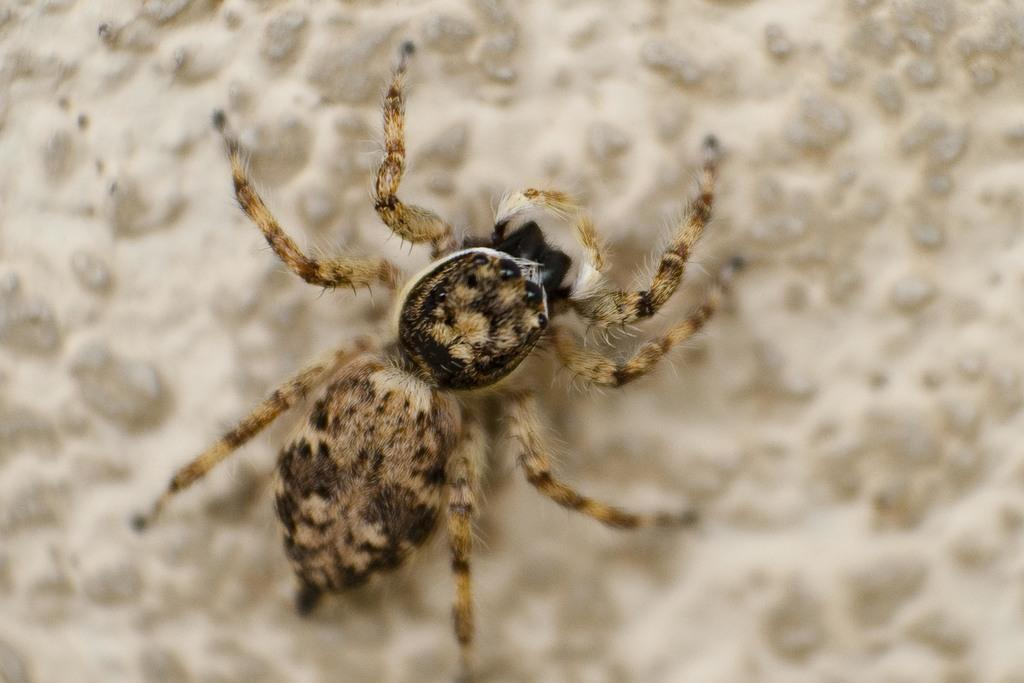What type of animal or creature is present in the image? There is a spider in the image. What type of chicken is hanging from the hook in the tree in the image? There is no chicken, hook, or tree present in the image; it only features a spider. 